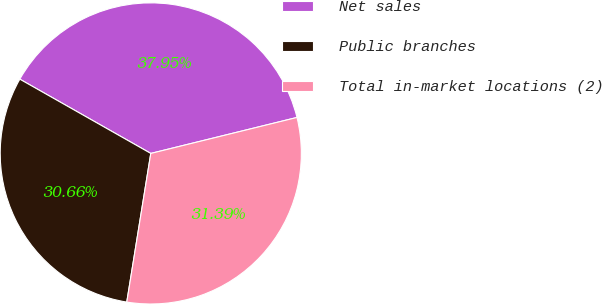Convert chart to OTSL. <chart><loc_0><loc_0><loc_500><loc_500><pie_chart><fcel>Net sales<fcel>Public branches<fcel>Total in-market locations (2)<nl><fcel>37.95%<fcel>30.66%<fcel>31.39%<nl></chart> 